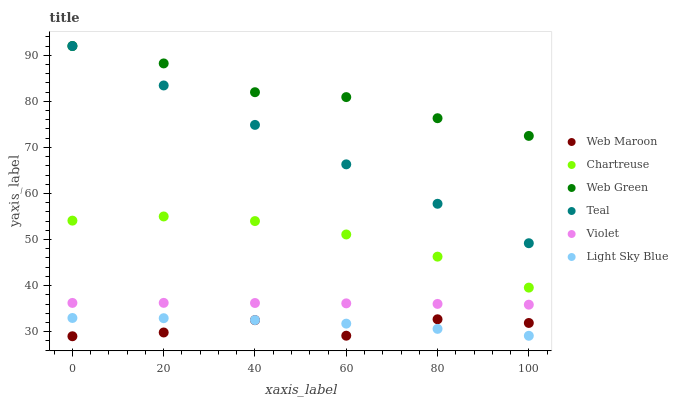Does Web Maroon have the minimum area under the curve?
Answer yes or no. Yes. Does Web Green have the maximum area under the curve?
Answer yes or no. Yes. Does Chartreuse have the minimum area under the curve?
Answer yes or no. No. Does Chartreuse have the maximum area under the curve?
Answer yes or no. No. Is Teal the smoothest?
Answer yes or no. Yes. Is Web Maroon the roughest?
Answer yes or no. Yes. Is Web Green the smoothest?
Answer yes or no. No. Is Web Green the roughest?
Answer yes or no. No. Does Web Maroon have the lowest value?
Answer yes or no. Yes. Does Chartreuse have the lowest value?
Answer yes or no. No. Does Teal have the highest value?
Answer yes or no. Yes. Does Chartreuse have the highest value?
Answer yes or no. No. Is Light Sky Blue less than Violet?
Answer yes or no. Yes. Is Web Green greater than Chartreuse?
Answer yes or no. Yes. Does Web Green intersect Teal?
Answer yes or no. Yes. Is Web Green less than Teal?
Answer yes or no. No. Is Web Green greater than Teal?
Answer yes or no. No. Does Light Sky Blue intersect Violet?
Answer yes or no. No. 